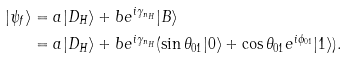Convert formula to latex. <formula><loc_0><loc_0><loc_500><loc_500>| \psi _ { f } \rangle & = a | D _ { H } \rangle + b e ^ { i \gamma _ { n _ { H } } } | B \rangle \\ & = a | D _ { H } \rangle + b e ^ { i \gamma _ { n _ { H } } } ( \sin \theta _ { 0 1 } | 0 \rangle + \cos \theta _ { 0 1 } e ^ { i \phi _ { 0 1 } } | 1 \rangle ) . \\</formula> 